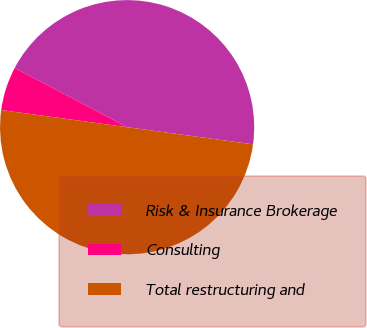<chart> <loc_0><loc_0><loc_500><loc_500><pie_chart><fcel>Risk & Insurance Brokerage<fcel>Consulting<fcel>Total restructuring and<nl><fcel>44.44%<fcel>5.56%<fcel>50.0%<nl></chart> 